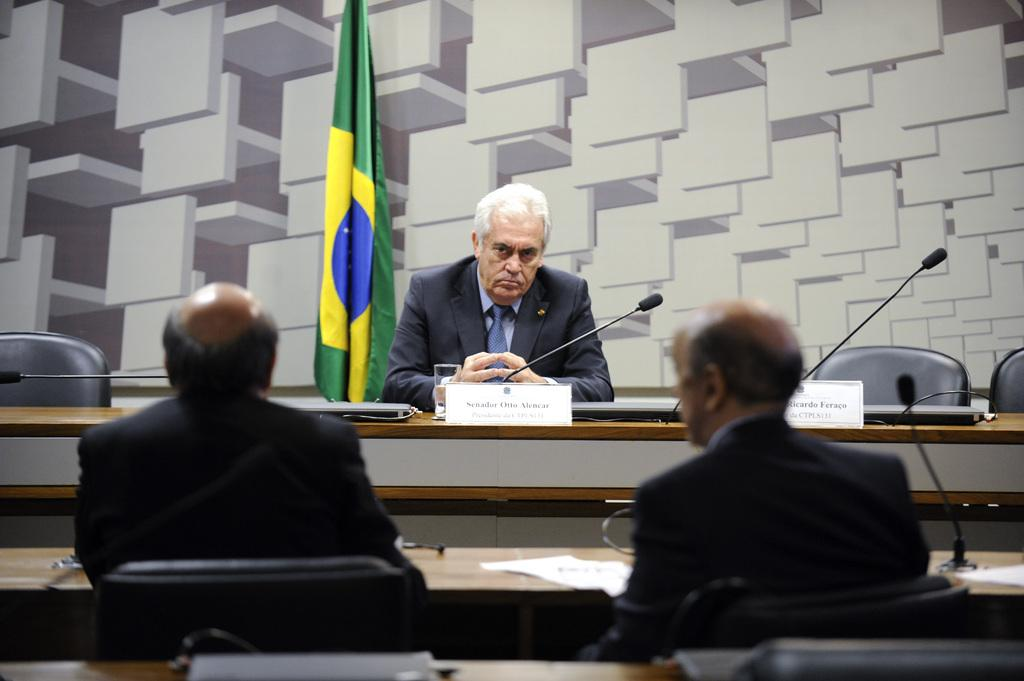How many people are in the image? There are three persons in the image. What are the people wearing? The three persons are wearing black color jackets. What type of furniture is present in the image? There are chairs and tables in the image. What objects can be seen on the tables? There are papers and microphones (mics) in the image. What is the flag associated with? The flag is present in the image, but its specific association is not clear. What type of beast can be seen carrying a basket in the image? There is no beast or basket present in the image. How many women are visible in the image? The provided facts do not mention the gender of the persons in the image, so it cannot be determined if there are any women present. 